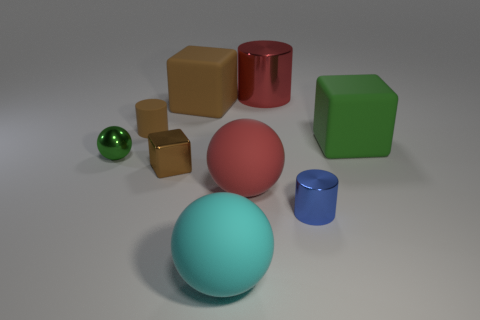There is a ball that is left of the cyan sphere; is it the same color as the rubber cube that is in front of the tiny rubber cylinder?
Your answer should be very brief. Yes. What material is the tiny brown object in front of the cylinder on the left side of the tiny brown shiny object made of?
Keep it short and to the point. Metal. Is there a brown shiny block that has the same size as the red shiny thing?
Provide a succinct answer. No. What number of objects are matte things that are on the left side of the large metallic cylinder or big things that are behind the big brown rubber object?
Your answer should be compact. 5. Does the metal cylinder in front of the big brown block have the same size as the brown cylinder that is in front of the big red cylinder?
Your answer should be very brief. Yes. There is a block that is in front of the large green rubber object; is there a large green rubber cube that is on the left side of it?
Ensure brevity in your answer.  No. There is a tiny blue metal cylinder; how many rubber spheres are behind it?
Ensure brevity in your answer.  1. What number of other things are the same color as the matte cylinder?
Offer a terse response. 2. Are there fewer small green spheres to the right of the small blue cylinder than tiny brown objects that are in front of the shiny sphere?
Your response must be concise. Yes. What number of objects are either matte cubes that are on the right side of the red shiny thing or brown cubes?
Provide a succinct answer. 3. 